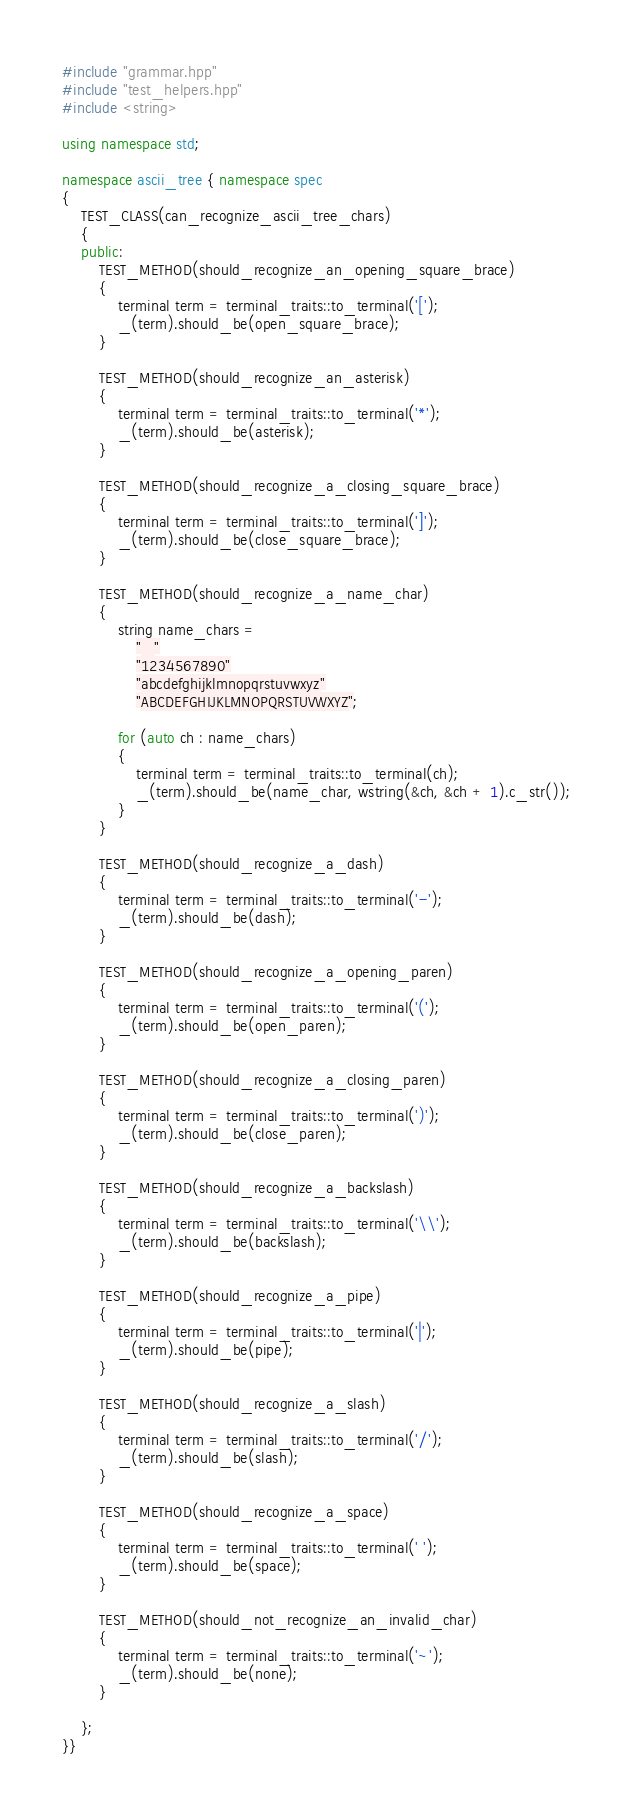Convert code to text. <code><loc_0><loc_0><loc_500><loc_500><_C++_>#include "grammar.hpp"
#include "test_helpers.hpp"
#include <string>

using namespace std;

namespace ascii_tree { namespace spec
{
    TEST_CLASS(can_recognize_ascii_tree_chars)
    {
    public:
        TEST_METHOD(should_recognize_an_opening_square_brace)
        {
            terminal term = terminal_traits::to_terminal('[');
            _(term).should_be(open_square_brace);
        }

        TEST_METHOD(should_recognize_an_asterisk)
        {
            terminal term = terminal_traits::to_terminal('*');
            _(term).should_be(asterisk);
        }

        TEST_METHOD(should_recognize_a_closing_square_brace)
        {
            terminal term = terminal_traits::to_terminal(']');
            _(term).should_be(close_square_brace);
        }

        TEST_METHOD(should_recognize_a_name_char)
        {
            string name_chars =
                "_"
                "1234567890"
                "abcdefghijklmnopqrstuvwxyz"
                "ABCDEFGHIJKLMNOPQRSTUVWXYZ";

            for (auto ch : name_chars)
            {
                terminal term = terminal_traits::to_terminal(ch);
                _(term).should_be(name_char, wstring(&ch, &ch + 1).c_str());
            }
        }

        TEST_METHOD(should_recognize_a_dash)
        {
            terminal term = terminal_traits::to_terminal('-');
            _(term).should_be(dash);
        }

        TEST_METHOD(should_recognize_a_opening_paren)
        {
            terminal term = terminal_traits::to_terminal('(');
            _(term).should_be(open_paren);
        }

        TEST_METHOD(should_recognize_a_closing_paren)
        {
            terminal term = terminal_traits::to_terminal(')');
            _(term).should_be(close_paren);
        }

        TEST_METHOD(should_recognize_a_backslash)
        {
            terminal term = terminal_traits::to_terminal('\\');
            _(term).should_be(backslash);
        }

        TEST_METHOD(should_recognize_a_pipe)
        {
            terminal term = terminal_traits::to_terminal('|');
            _(term).should_be(pipe);
        }

        TEST_METHOD(should_recognize_a_slash)
        {
            terminal term = terminal_traits::to_terminal('/');
            _(term).should_be(slash);
        }

        TEST_METHOD(should_recognize_a_space)
        {
            terminal term = terminal_traits::to_terminal(' ');
            _(term).should_be(space);
        }

        TEST_METHOD(should_not_recognize_an_invalid_char)
        {
            terminal term = terminal_traits::to_terminal('~');
            _(term).should_be(none);
        }

    };
}}
</code> 